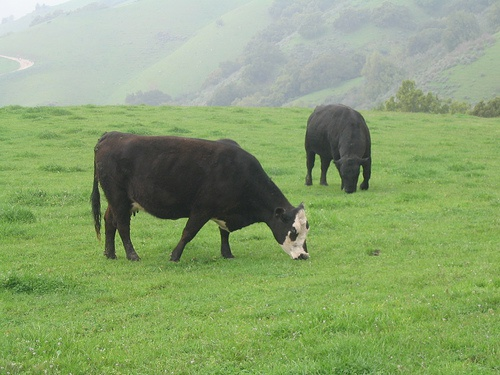Describe the objects in this image and their specific colors. I can see cow in white, black, gray, and darkgreen tones and cow in white, gray, black, and lightgreen tones in this image. 